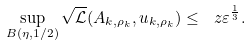Convert formula to latex. <formula><loc_0><loc_0><loc_500><loc_500>\sup _ { B ( \eta , 1 / 2 ) } \sqrt { \mathcal { L } } ( A _ { k , \rho _ { k } } , u _ { k , \rho _ { k } } ) \leq \ z \varepsilon ^ { \frac { 1 } { 3 } } .</formula> 